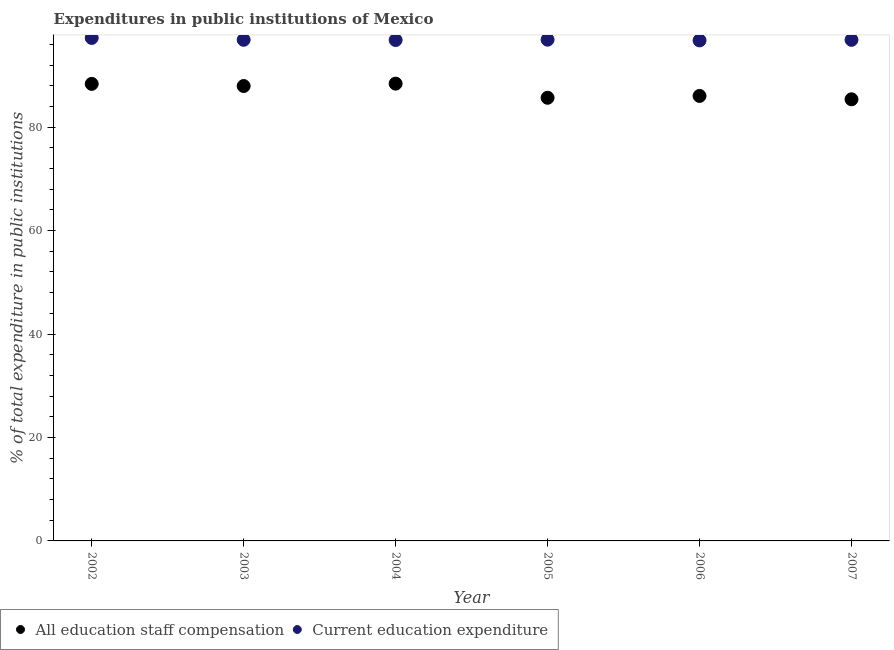What is the expenditure in staff compensation in 2006?
Your answer should be compact. 86.03. Across all years, what is the maximum expenditure in education?
Your answer should be very brief. 97.24. Across all years, what is the minimum expenditure in staff compensation?
Give a very brief answer. 85.38. What is the total expenditure in staff compensation in the graph?
Make the answer very short. 521.78. What is the difference between the expenditure in staff compensation in 2003 and that in 2006?
Provide a succinct answer. 1.92. What is the difference between the expenditure in staff compensation in 2003 and the expenditure in education in 2007?
Ensure brevity in your answer.  -8.93. What is the average expenditure in staff compensation per year?
Your response must be concise. 86.96. In the year 2002, what is the difference between the expenditure in education and expenditure in staff compensation?
Offer a terse response. 8.88. In how many years, is the expenditure in staff compensation greater than 32 %?
Ensure brevity in your answer.  6. What is the ratio of the expenditure in staff compensation in 2002 to that in 2003?
Make the answer very short. 1. Is the expenditure in staff compensation in 2002 less than that in 2003?
Offer a terse response. No. Is the difference between the expenditure in staff compensation in 2002 and 2006 greater than the difference between the expenditure in education in 2002 and 2006?
Provide a short and direct response. Yes. What is the difference between the highest and the second highest expenditure in education?
Provide a succinct answer. 0.34. What is the difference between the highest and the lowest expenditure in education?
Offer a very short reply. 0.48. In how many years, is the expenditure in education greater than the average expenditure in education taken over all years?
Ensure brevity in your answer.  1. Does the expenditure in staff compensation monotonically increase over the years?
Ensure brevity in your answer.  No. Is the expenditure in staff compensation strictly less than the expenditure in education over the years?
Your response must be concise. Yes. What is the difference between two consecutive major ticks on the Y-axis?
Provide a succinct answer. 20. Does the graph contain grids?
Provide a short and direct response. No. How many legend labels are there?
Keep it short and to the point. 2. How are the legend labels stacked?
Offer a very short reply. Horizontal. What is the title of the graph?
Make the answer very short. Expenditures in public institutions of Mexico. What is the label or title of the X-axis?
Offer a very short reply. Year. What is the label or title of the Y-axis?
Your answer should be very brief. % of total expenditure in public institutions. What is the % of total expenditure in public institutions in All education staff compensation in 2002?
Offer a very short reply. 88.36. What is the % of total expenditure in public institutions of Current education expenditure in 2002?
Ensure brevity in your answer.  97.24. What is the % of total expenditure in public institutions in All education staff compensation in 2003?
Make the answer very short. 87.94. What is the % of total expenditure in public institutions of Current education expenditure in 2003?
Your response must be concise. 96.88. What is the % of total expenditure in public institutions of All education staff compensation in 2004?
Your answer should be compact. 88.4. What is the % of total expenditure in public institutions of Current education expenditure in 2004?
Your response must be concise. 96.83. What is the % of total expenditure in public institutions in All education staff compensation in 2005?
Offer a terse response. 85.67. What is the % of total expenditure in public institutions in Current education expenditure in 2005?
Keep it short and to the point. 96.9. What is the % of total expenditure in public institutions in All education staff compensation in 2006?
Your answer should be very brief. 86.03. What is the % of total expenditure in public institutions of Current education expenditure in 2006?
Give a very brief answer. 96.76. What is the % of total expenditure in public institutions in All education staff compensation in 2007?
Make the answer very short. 85.38. What is the % of total expenditure in public institutions of Current education expenditure in 2007?
Offer a terse response. 96.87. Across all years, what is the maximum % of total expenditure in public institutions in All education staff compensation?
Offer a terse response. 88.4. Across all years, what is the maximum % of total expenditure in public institutions in Current education expenditure?
Offer a terse response. 97.24. Across all years, what is the minimum % of total expenditure in public institutions in All education staff compensation?
Your answer should be compact. 85.38. Across all years, what is the minimum % of total expenditure in public institutions in Current education expenditure?
Give a very brief answer. 96.76. What is the total % of total expenditure in public institutions of All education staff compensation in the graph?
Your response must be concise. 521.78. What is the total % of total expenditure in public institutions of Current education expenditure in the graph?
Offer a terse response. 581.49. What is the difference between the % of total expenditure in public institutions in All education staff compensation in 2002 and that in 2003?
Make the answer very short. 0.41. What is the difference between the % of total expenditure in public institutions of Current education expenditure in 2002 and that in 2003?
Make the answer very short. 0.36. What is the difference between the % of total expenditure in public institutions in All education staff compensation in 2002 and that in 2004?
Give a very brief answer. -0.05. What is the difference between the % of total expenditure in public institutions of Current education expenditure in 2002 and that in 2004?
Offer a terse response. 0.4. What is the difference between the % of total expenditure in public institutions in All education staff compensation in 2002 and that in 2005?
Ensure brevity in your answer.  2.69. What is the difference between the % of total expenditure in public institutions of Current education expenditure in 2002 and that in 2005?
Your answer should be compact. 0.34. What is the difference between the % of total expenditure in public institutions in All education staff compensation in 2002 and that in 2006?
Provide a succinct answer. 2.33. What is the difference between the % of total expenditure in public institutions in Current education expenditure in 2002 and that in 2006?
Give a very brief answer. 0.48. What is the difference between the % of total expenditure in public institutions of All education staff compensation in 2002 and that in 2007?
Your answer should be compact. 2.98. What is the difference between the % of total expenditure in public institutions in Current education expenditure in 2002 and that in 2007?
Offer a terse response. 0.37. What is the difference between the % of total expenditure in public institutions of All education staff compensation in 2003 and that in 2004?
Offer a very short reply. -0.46. What is the difference between the % of total expenditure in public institutions in Current education expenditure in 2003 and that in 2004?
Provide a short and direct response. 0.04. What is the difference between the % of total expenditure in public institutions of All education staff compensation in 2003 and that in 2005?
Your answer should be very brief. 2.27. What is the difference between the % of total expenditure in public institutions in Current education expenditure in 2003 and that in 2005?
Provide a short and direct response. -0.02. What is the difference between the % of total expenditure in public institutions of All education staff compensation in 2003 and that in 2006?
Provide a short and direct response. 1.92. What is the difference between the % of total expenditure in public institutions of Current education expenditure in 2003 and that in 2006?
Provide a succinct answer. 0.12. What is the difference between the % of total expenditure in public institutions in All education staff compensation in 2003 and that in 2007?
Provide a succinct answer. 2.56. What is the difference between the % of total expenditure in public institutions of Current education expenditure in 2003 and that in 2007?
Keep it short and to the point. 0.01. What is the difference between the % of total expenditure in public institutions of All education staff compensation in 2004 and that in 2005?
Offer a very short reply. 2.73. What is the difference between the % of total expenditure in public institutions in Current education expenditure in 2004 and that in 2005?
Make the answer very short. -0.07. What is the difference between the % of total expenditure in public institutions of All education staff compensation in 2004 and that in 2006?
Ensure brevity in your answer.  2.38. What is the difference between the % of total expenditure in public institutions of Current education expenditure in 2004 and that in 2006?
Your answer should be compact. 0.07. What is the difference between the % of total expenditure in public institutions of All education staff compensation in 2004 and that in 2007?
Give a very brief answer. 3.02. What is the difference between the % of total expenditure in public institutions in Current education expenditure in 2004 and that in 2007?
Your answer should be compact. -0.04. What is the difference between the % of total expenditure in public institutions in All education staff compensation in 2005 and that in 2006?
Provide a succinct answer. -0.35. What is the difference between the % of total expenditure in public institutions in Current education expenditure in 2005 and that in 2006?
Offer a terse response. 0.14. What is the difference between the % of total expenditure in public institutions in All education staff compensation in 2005 and that in 2007?
Ensure brevity in your answer.  0.29. What is the difference between the % of total expenditure in public institutions of Current education expenditure in 2005 and that in 2007?
Offer a terse response. 0.03. What is the difference between the % of total expenditure in public institutions of All education staff compensation in 2006 and that in 2007?
Provide a short and direct response. 0.65. What is the difference between the % of total expenditure in public institutions in Current education expenditure in 2006 and that in 2007?
Your answer should be compact. -0.11. What is the difference between the % of total expenditure in public institutions in All education staff compensation in 2002 and the % of total expenditure in public institutions in Current education expenditure in 2003?
Offer a terse response. -8.52. What is the difference between the % of total expenditure in public institutions in All education staff compensation in 2002 and the % of total expenditure in public institutions in Current education expenditure in 2004?
Provide a short and direct response. -8.48. What is the difference between the % of total expenditure in public institutions in All education staff compensation in 2002 and the % of total expenditure in public institutions in Current education expenditure in 2005?
Give a very brief answer. -8.55. What is the difference between the % of total expenditure in public institutions in All education staff compensation in 2002 and the % of total expenditure in public institutions in Current education expenditure in 2006?
Offer a terse response. -8.4. What is the difference between the % of total expenditure in public institutions in All education staff compensation in 2002 and the % of total expenditure in public institutions in Current education expenditure in 2007?
Keep it short and to the point. -8.51. What is the difference between the % of total expenditure in public institutions of All education staff compensation in 2003 and the % of total expenditure in public institutions of Current education expenditure in 2004?
Provide a succinct answer. -8.89. What is the difference between the % of total expenditure in public institutions of All education staff compensation in 2003 and the % of total expenditure in public institutions of Current education expenditure in 2005?
Your answer should be compact. -8.96. What is the difference between the % of total expenditure in public institutions of All education staff compensation in 2003 and the % of total expenditure in public institutions of Current education expenditure in 2006?
Offer a very short reply. -8.82. What is the difference between the % of total expenditure in public institutions in All education staff compensation in 2003 and the % of total expenditure in public institutions in Current education expenditure in 2007?
Your answer should be very brief. -8.93. What is the difference between the % of total expenditure in public institutions of All education staff compensation in 2004 and the % of total expenditure in public institutions of Current education expenditure in 2005?
Offer a terse response. -8.5. What is the difference between the % of total expenditure in public institutions of All education staff compensation in 2004 and the % of total expenditure in public institutions of Current education expenditure in 2006?
Keep it short and to the point. -8.36. What is the difference between the % of total expenditure in public institutions in All education staff compensation in 2004 and the % of total expenditure in public institutions in Current education expenditure in 2007?
Provide a succinct answer. -8.47. What is the difference between the % of total expenditure in public institutions in All education staff compensation in 2005 and the % of total expenditure in public institutions in Current education expenditure in 2006?
Provide a short and direct response. -11.09. What is the difference between the % of total expenditure in public institutions in All education staff compensation in 2005 and the % of total expenditure in public institutions in Current education expenditure in 2007?
Provide a succinct answer. -11.2. What is the difference between the % of total expenditure in public institutions in All education staff compensation in 2006 and the % of total expenditure in public institutions in Current education expenditure in 2007?
Offer a terse response. -10.84. What is the average % of total expenditure in public institutions in All education staff compensation per year?
Keep it short and to the point. 86.96. What is the average % of total expenditure in public institutions of Current education expenditure per year?
Keep it short and to the point. 96.91. In the year 2002, what is the difference between the % of total expenditure in public institutions of All education staff compensation and % of total expenditure in public institutions of Current education expenditure?
Offer a very short reply. -8.88. In the year 2003, what is the difference between the % of total expenditure in public institutions in All education staff compensation and % of total expenditure in public institutions in Current education expenditure?
Your answer should be compact. -8.94. In the year 2004, what is the difference between the % of total expenditure in public institutions of All education staff compensation and % of total expenditure in public institutions of Current education expenditure?
Give a very brief answer. -8.43. In the year 2005, what is the difference between the % of total expenditure in public institutions of All education staff compensation and % of total expenditure in public institutions of Current education expenditure?
Your response must be concise. -11.23. In the year 2006, what is the difference between the % of total expenditure in public institutions of All education staff compensation and % of total expenditure in public institutions of Current education expenditure?
Provide a short and direct response. -10.74. In the year 2007, what is the difference between the % of total expenditure in public institutions in All education staff compensation and % of total expenditure in public institutions in Current education expenditure?
Ensure brevity in your answer.  -11.49. What is the ratio of the % of total expenditure in public institutions of All education staff compensation in 2002 to that in 2003?
Your response must be concise. 1. What is the ratio of the % of total expenditure in public institutions in Current education expenditure in 2002 to that in 2003?
Your answer should be compact. 1. What is the ratio of the % of total expenditure in public institutions of All education staff compensation in 2002 to that in 2004?
Your answer should be compact. 1. What is the ratio of the % of total expenditure in public institutions in Current education expenditure in 2002 to that in 2004?
Give a very brief answer. 1. What is the ratio of the % of total expenditure in public institutions of All education staff compensation in 2002 to that in 2005?
Make the answer very short. 1.03. What is the ratio of the % of total expenditure in public institutions in All education staff compensation in 2002 to that in 2006?
Give a very brief answer. 1.03. What is the ratio of the % of total expenditure in public institutions in Current education expenditure in 2002 to that in 2006?
Offer a terse response. 1. What is the ratio of the % of total expenditure in public institutions of All education staff compensation in 2002 to that in 2007?
Offer a terse response. 1.03. What is the ratio of the % of total expenditure in public institutions in Current education expenditure in 2002 to that in 2007?
Provide a short and direct response. 1. What is the ratio of the % of total expenditure in public institutions in All education staff compensation in 2003 to that in 2005?
Give a very brief answer. 1.03. What is the ratio of the % of total expenditure in public institutions in All education staff compensation in 2003 to that in 2006?
Offer a very short reply. 1.02. What is the ratio of the % of total expenditure in public institutions in Current education expenditure in 2003 to that in 2006?
Keep it short and to the point. 1. What is the ratio of the % of total expenditure in public institutions of Current education expenditure in 2003 to that in 2007?
Offer a terse response. 1. What is the ratio of the % of total expenditure in public institutions in All education staff compensation in 2004 to that in 2005?
Your response must be concise. 1.03. What is the ratio of the % of total expenditure in public institutions in Current education expenditure in 2004 to that in 2005?
Provide a succinct answer. 1. What is the ratio of the % of total expenditure in public institutions in All education staff compensation in 2004 to that in 2006?
Your response must be concise. 1.03. What is the ratio of the % of total expenditure in public institutions in Current education expenditure in 2004 to that in 2006?
Your answer should be compact. 1. What is the ratio of the % of total expenditure in public institutions in All education staff compensation in 2004 to that in 2007?
Your answer should be very brief. 1.04. What is the ratio of the % of total expenditure in public institutions of All education staff compensation in 2005 to that in 2006?
Make the answer very short. 1. What is the ratio of the % of total expenditure in public institutions of Current education expenditure in 2005 to that in 2006?
Your response must be concise. 1. What is the ratio of the % of total expenditure in public institutions in All education staff compensation in 2005 to that in 2007?
Ensure brevity in your answer.  1. What is the ratio of the % of total expenditure in public institutions in Current education expenditure in 2005 to that in 2007?
Provide a succinct answer. 1. What is the ratio of the % of total expenditure in public institutions in All education staff compensation in 2006 to that in 2007?
Offer a terse response. 1.01. What is the difference between the highest and the second highest % of total expenditure in public institutions in All education staff compensation?
Ensure brevity in your answer.  0.05. What is the difference between the highest and the second highest % of total expenditure in public institutions of Current education expenditure?
Make the answer very short. 0.34. What is the difference between the highest and the lowest % of total expenditure in public institutions of All education staff compensation?
Keep it short and to the point. 3.02. What is the difference between the highest and the lowest % of total expenditure in public institutions of Current education expenditure?
Give a very brief answer. 0.48. 